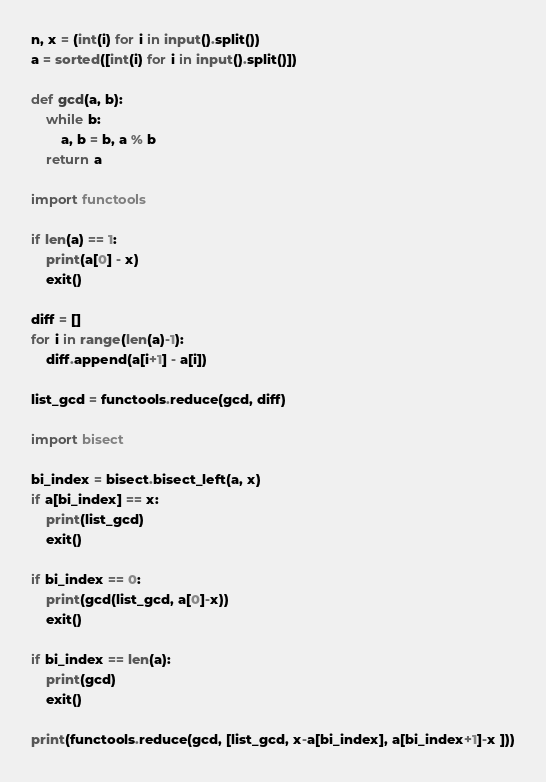Convert code to text. <code><loc_0><loc_0><loc_500><loc_500><_Python_>n, x = (int(i) for i in input().split()) 
a = sorted([int(i) for i in input().split()])

def gcd(a, b):
	while b:
		a, b = b, a % b
	return a

import functools

if len(a) == 1:
    print(a[0] - x)
    exit()

diff = []
for i in range(len(a)-1):
    diff.append(a[i+1] - a[i])

list_gcd = functools.reduce(gcd, diff)

import bisect

bi_index = bisect.bisect_left(a, x)
if a[bi_index] == x:
    print(list_gcd)
    exit()

if bi_index == 0:
    print(gcd(list_gcd, a[0]-x))
    exit()

if bi_index == len(a):
    print(gcd)
    exit()

print(functools.reduce(gcd, [list_gcd, x-a[bi_index], a[bi_index+1]-x ]))
</code> 